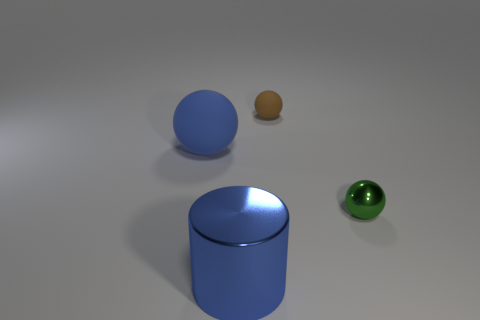There is a small thing that is behind the small green sphere; is its color the same as the big shiny cylinder?
Ensure brevity in your answer.  No. There is a large blue object in front of the big sphere; what number of blue metal cylinders are behind it?
Your answer should be compact. 0. What color is the ball that is the same size as the metal cylinder?
Provide a succinct answer. Blue. What material is the object left of the big blue metal object?
Provide a succinct answer. Rubber. The object that is both in front of the blue sphere and on the right side of the cylinder is made of what material?
Give a very brief answer. Metal. Does the matte thing that is on the right side of the cylinder have the same size as the tiny green ball?
Provide a succinct answer. Yes. The green metal thing is what shape?
Your answer should be very brief. Sphere. What number of metal things are the same shape as the big blue matte thing?
Your answer should be compact. 1. What number of things are both to the left of the tiny metal object and on the right side of the blue ball?
Offer a terse response. 2. The tiny matte ball is what color?
Offer a terse response. Brown. 